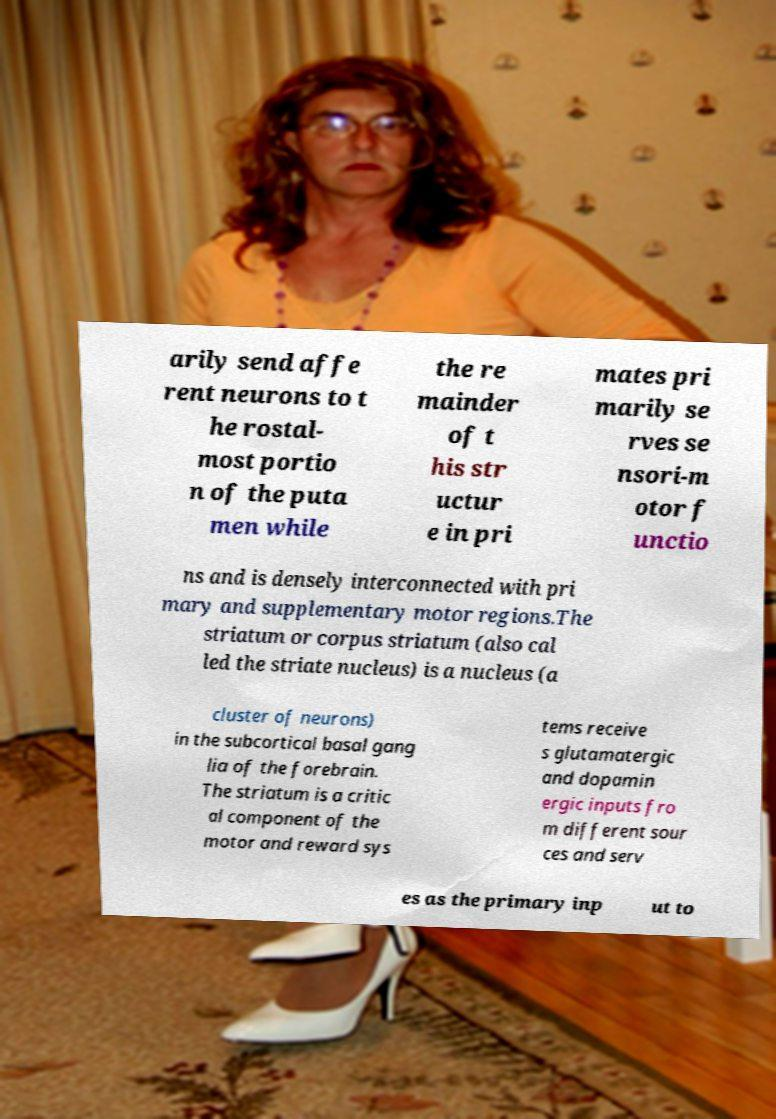Please read and relay the text visible in this image. What does it say? arily send affe rent neurons to t he rostal- most portio n of the puta men while the re mainder of t his str uctur e in pri mates pri marily se rves se nsori-m otor f unctio ns and is densely interconnected with pri mary and supplementary motor regions.The striatum or corpus striatum (also cal led the striate nucleus) is a nucleus (a cluster of neurons) in the subcortical basal gang lia of the forebrain. The striatum is a critic al component of the motor and reward sys tems receive s glutamatergic and dopamin ergic inputs fro m different sour ces and serv es as the primary inp ut to 